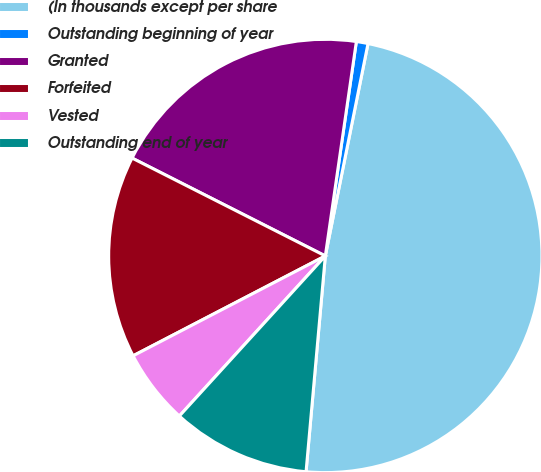<chart> <loc_0><loc_0><loc_500><loc_500><pie_chart><fcel>(In thousands except per share<fcel>Outstanding beginning of year<fcel>Granted<fcel>Forfeited<fcel>Vested<fcel>Outstanding end of year<nl><fcel>48.27%<fcel>0.87%<fcel>19.83%<fcel>15.09%<fcel>5.61%<fcel>10.35%<nl></chart> 